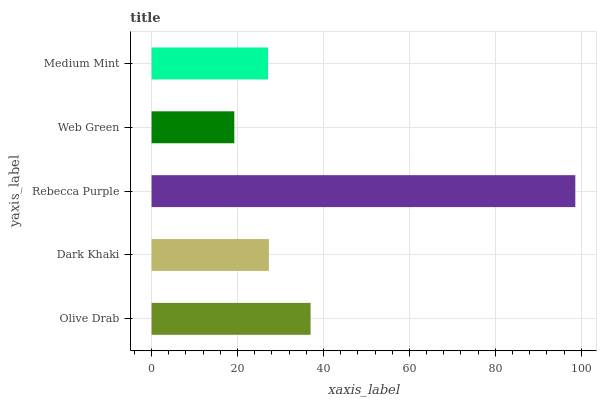Is Web Green the minimum?
Answer yes or no. Yes. Is Rebecca Purple the maximum?
Answer yes or no. Yes. Is Dark Khaki the minimum?
Answer yes or no. No. Is Dark Khaki the maximum?
Answer yes or no. No. Is Olive Drab greater than Dark Khaki?
Answer yes or no. Yes. Is Dark Khaki less than Olive Drab?
Answer yes or no. Yes. Is Dark Khaki greater than Olive Drab?
Answer yes or no. No. Is Olive Drab less than Dark Khaki?
Answer yes or no. No. Is Dark Khaki the high median?
Answer yes or no. Yes. Is Dark Khaki the low median?
Answer yes or no. Yes. Is Web Green the high median?
Answer yes or no. No. Is Olive Drab the low median?
Answer yes or no. No. 